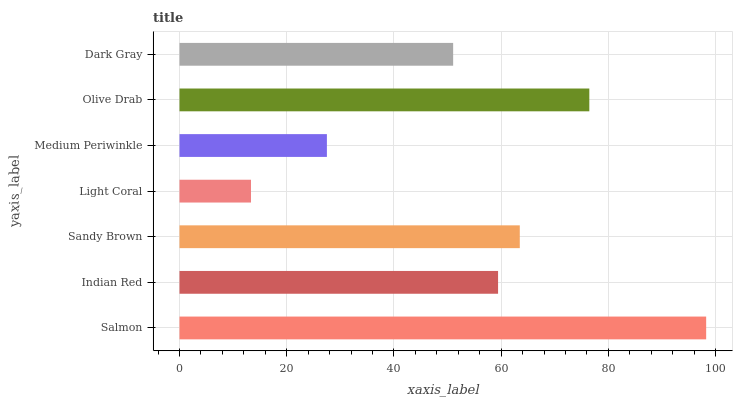Is Light Coral the minimum?
Answer yes or no. Yes. Is Salmon the maximum?
Answer yes or no. Yes. Is Indian Red the minimum?
Answer yes or no. No. Is Indian Red the maximum?
Answer yes or no. No. Is Salmon greater than Indian Red?
Answer yes or no. Yes. Is Indian Red less than Salmon?
Answer yes or no. Yes. Is Indian Red greater than Salmon?
Answer yes or no. No. Is Salmon less than Indian Red?
Answer yes or no. No. Is Indian Red the high median?
Answer yes or no. Yes. Is Indian Red the low median?
Answer yes or no. Yes. Is Olive Drab the high median?
Answer yes or no. No. Is Medium Periwinkle the low median?
Answer yes or no. No. 